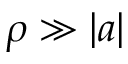<formula> <loc_0><loc_0><loc_500><loc_500>\rho \gg | a |</formula> 